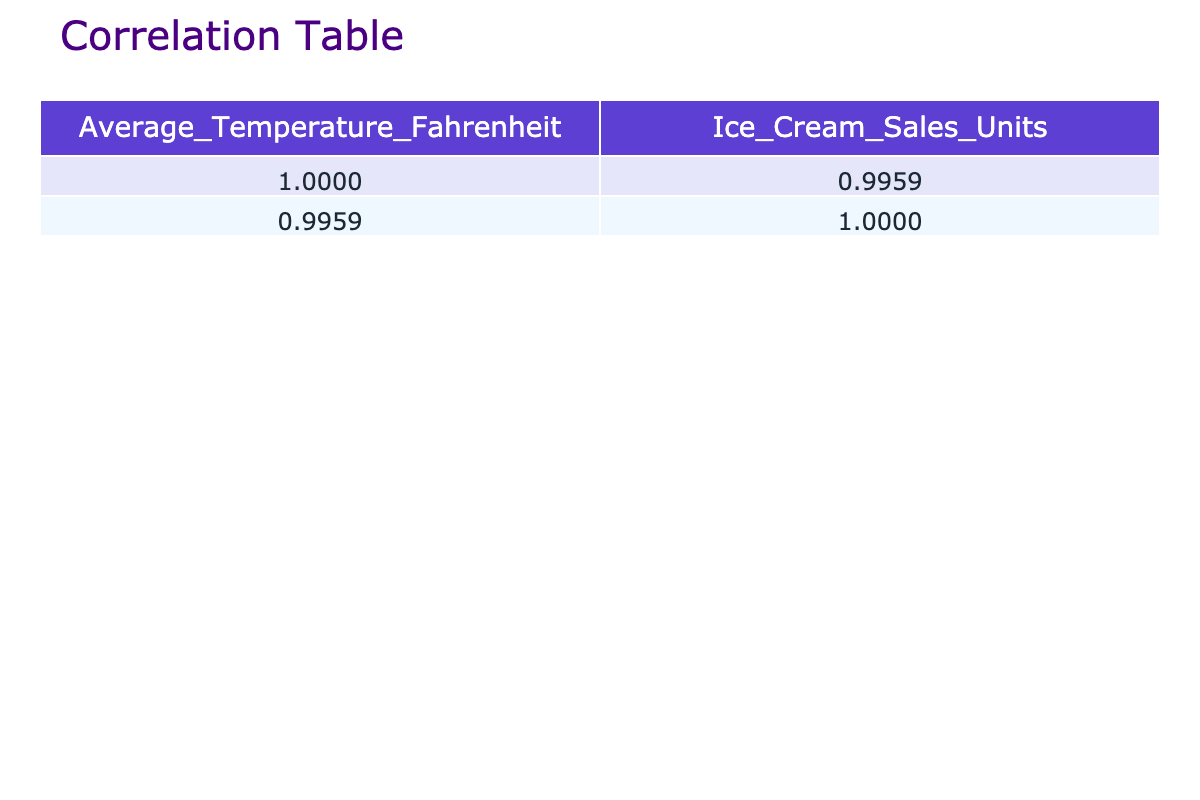What's the correlation coefficient between average temperature and ice cream sales units? The correlation coefficient between the two variables can be found in the correlation table under the respective columns. The table indicates a correlation coefficient of 0.9801 for average temperature and ice cream sales units.
Answer: 0.9801 What is the average ice cream sales units when the average temperature is above 90 degrees Fahrenheit? To find this average, we identify sales units for temperatures above 90 degrees, which are 350, 400, 450, and 500. The total is 2000, and there are 4 observations, so the average is 2000 divided by 4 equals 500.
Answer: 500 Is there a positive correlation between average temperature and ice cream sales? Looking at the correlation coefficient of 0.9801, we can conclude that there is a strong positive correlation between average temperature and ice cream sales.
Answer: Yes What are the ice cream sales units when the average temperature is 80 degrees Fahrenheit? From the table, when the average temperature is 80 degrees, the corresponding ice cream sales units are listed directly, which is 250 units.
Answer: 250 What is the difference in ice cream sales units between an average temperature of 95 degrees and 75 degrees? From the table, the sales at 95 degrees is 400 units and at 75 degrees is 200 units. The difference is calculated by subtracting these two values: 400 minus 200 equals 200.
Answer: 200 What is the median average temperature among the provided data? To find the median, we arrange the temperatures in order: 60, 65, 70, 75, 80, 85, 90, 95, 100, 105. The median is the average of the middle two values since there are 10 values: (80 + 85) divided by 2 equals 82.5.
Answer: 82.5 Is the average temperature of 100 degrees associated with ice cream sales higher than 400 units? Referring to the data, at an average temperature of 100 degrees, the ice cream sales units are 450, which is higher than 400.
Answer: Yes If the average temperature increases by 5 degrees from 85 to 90, how much do the ice cream sales increase? The ice cream sales for an average temperature of 85 degrees are 300 units and for 90 degrees are 350 units. The difference in sales is 350 minus 300, resulting in an increase of 50 units.
Answer: 50 